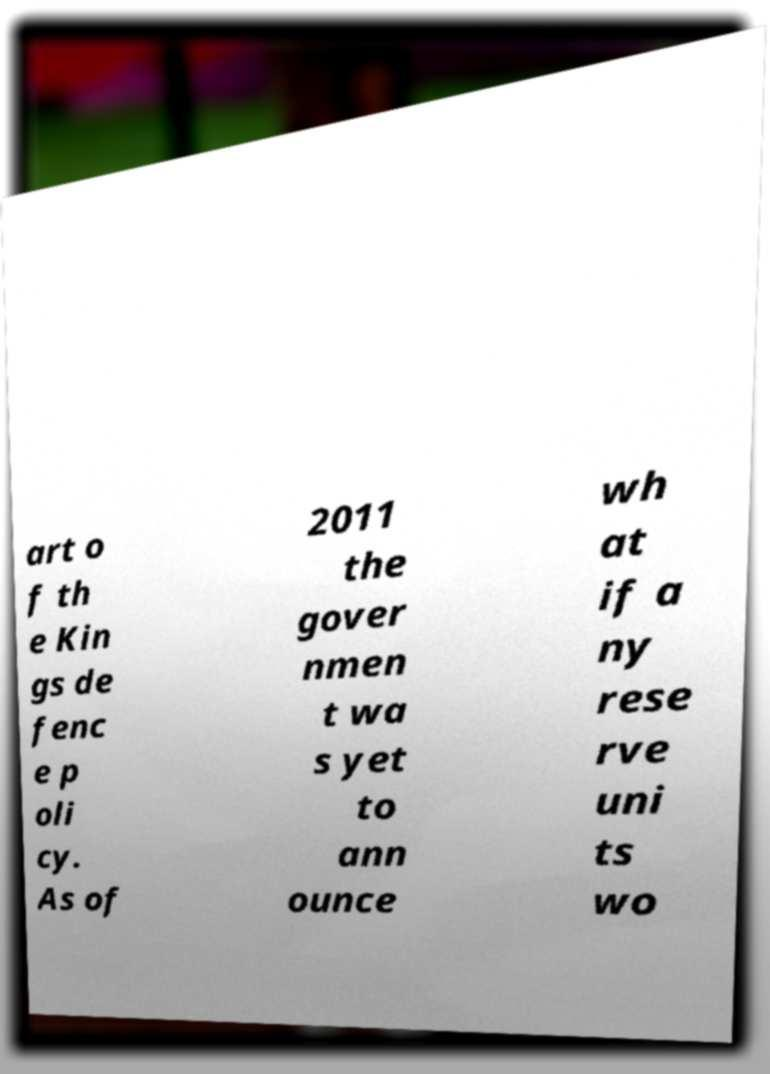Could you assist in decoding the text presented in this image and type it out clearly? art o f th e Kin gs de fenc e p oli cy. As of 2011 the gover nmen t wa s yet to ann ounce wh at if a ny rese rve uni ts wo 